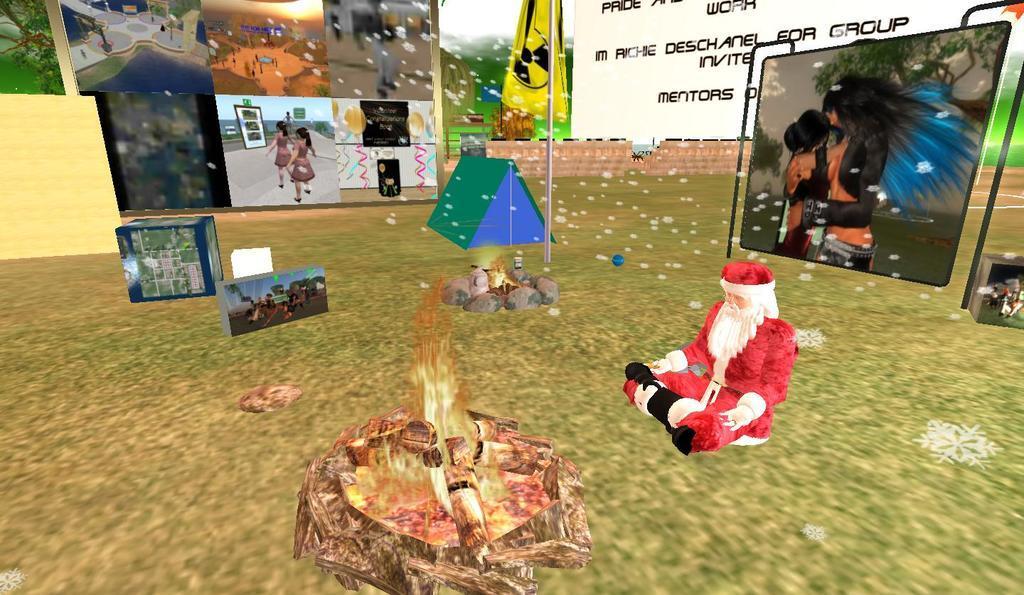Please provide a concise description of this image. This is an animated image where we can see the fireplace, a person in the Santa Claus dress, we can see tent, some objects, yellow color flag, projector screen, the wall and white color banner in the background. 